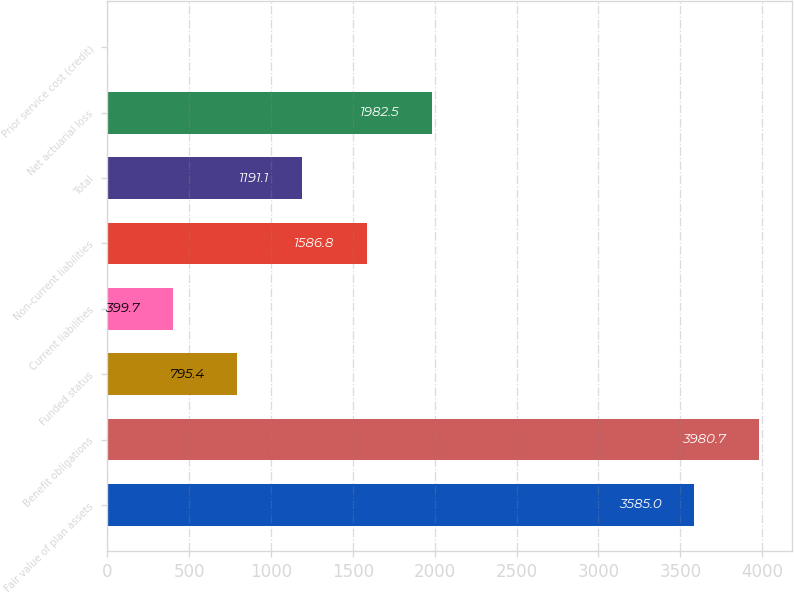Convert chart to OTSL. <chart><loc_0><loc_0><loc_500><loc_500><bar_chart><fcel>Fair value of plan assets<fcel>Benefit obligations<fcel>Funded status<fcel>Current liabilities<fcel>Non-current liabilities<fcel>Total<fcel>Net actuarial loss<fcel>Prior service cost (credit)<nl><fcel>3585<fcel>3980.7<fcel>795.4<fcel>399.7<fcel>1586.8<fcel>1191.1<fcel>1982.5<fcel>4<nl></chart> 